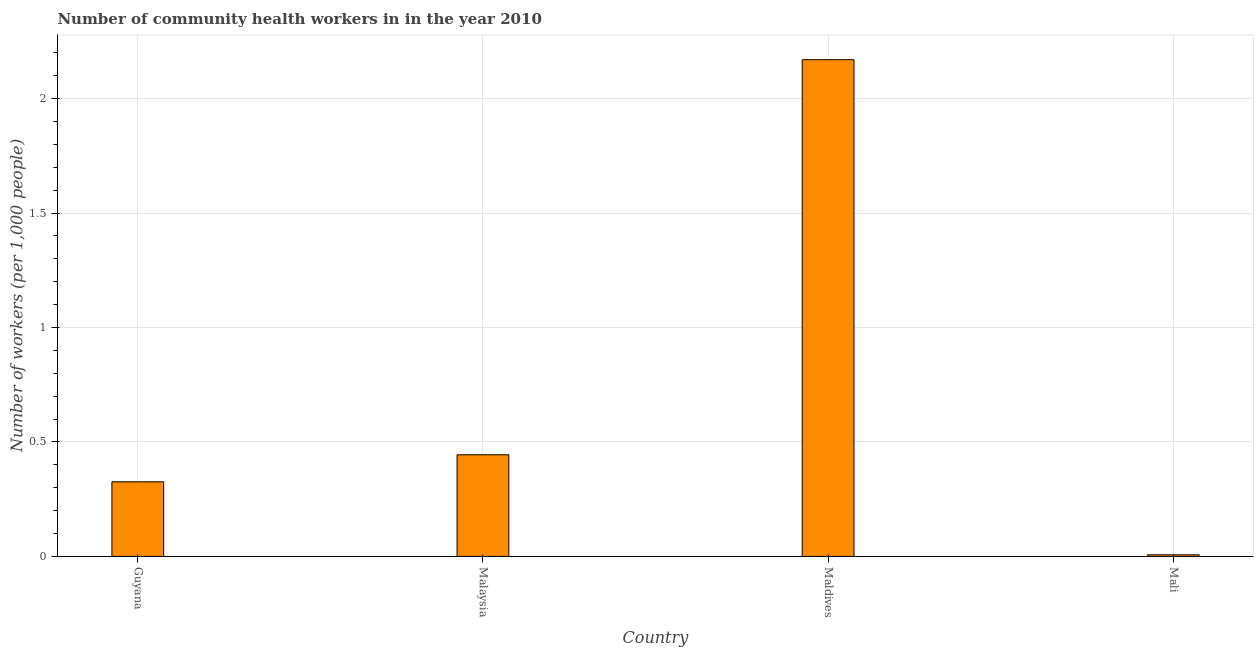What is the title of the graph?
Your response must be concise. Number of community health workers in in the year 2010. What is the label or title of the X-axis?
Provide a succinct answer. Country. What is the label or title of the Y-axis?
Make the answer very short. Number of workers (per 1,0 people). What is the number of community health workers in Malaysia?
Provide a succinct answer. 0.44. Across all countries, what is the maximum number of community health workers?
Offer a terse response. 2.17. Across all countries, what is the minimum number of community health workers?
Your answer should be very brief. 0.01. In which country was the number of community health workers maximum?
Provide a short and direct response. Maldives. In which country was the number of community health workers minimum?
Your response must be concise. Mali. What is the sum of the number of community health workers?
Ensure brevity in your answer.  2.95. What is the difference between the number of community health workers in Malaysia and Mali?
Your response must be concise. 0.44. What is the average number of community health workers per country?
Offer a terse response. 0.74. What is the median number of community health workers?
Provide a short and direct response. 0.39. What is the ratio of the number of community health workers in Malaysia to that in Mali?
Offer a terse response. 63.43. Is the number of community health workers in Maldives less than that in Mali?
Your answer should be compact. No. What is the difference between the highest and the second highest number of community health workers?
Make the answer very short. 1.73. What is the difference between the highest and the lowest number of community health workers?
Keep it short and to the point. 2.16. Are all the bars in the graph horizontal?
Offer a terse response. No. How many countries are there in the graph?
Offer a terse response. 4. Are the values on the major ticks of Y-axis written in scientific E-notation?
Provide a short and direct response. No. What is the Number of workers (per 1,000 people) in Guyana?
Offer a terse response. 0.33. What is the Number of workers (per 1,000 people) in Malaysia?
Ensure brevity in your answer.  0.44. What is the Number of workers (per 1,000 people) in Maldives?
Your response must be concise. 2.17. What is the Number of workers (per 1,000 people) of Mali?
Offer a very short reply. 0.01. What is the difference between the Number of workers (per 1,000 people) in Guyana and Malaysia?
Your response must be concise. -0.12. What is the difference between the Number of workers (per 1,000 people) in Guyana and Maldives?
Your response must be concise. -1.84. What is the difference between the Number of workers (per 1,000 people) in Guyana and Mali?
Your answer should be very brief. 0.32. What is the difference between the Number of workers (per 1,000 people) in Malaysia and Maldives?
Provide a short and direct response. -1.73. What is the difference between the Number of workers (per 1,000 people) in Malaysia and Mali?
Provide a short and direct response. 0.44. What is the difference between the Number of workers (per 1,000 people) in Maldives and Mali?
Your answer should be compact. 2.16. What is the ratio of the Number of workers (per 1,000 people) in Guyana to that in Malaysia?
Your answer should be very brief. 0.73. What is the ratio of the Number of workers (per 1,000 people) in Guyana to that in Mali?
Your answer should be very brief. 46.57. What is the ratio of the Number of workers (per 1,000 people) in Malaysia to that in Maldives?
Keep it short and to the point. 0.2. What is the ratio of the Number of workers (per 1,000 people) in Malaysia to that in Mali?
Keep it short and to the point. 63.43. What is the ratio of the Number of workers (per 1,000 people) in Maldives to that in Mali?
Your response must be concise. 310. 